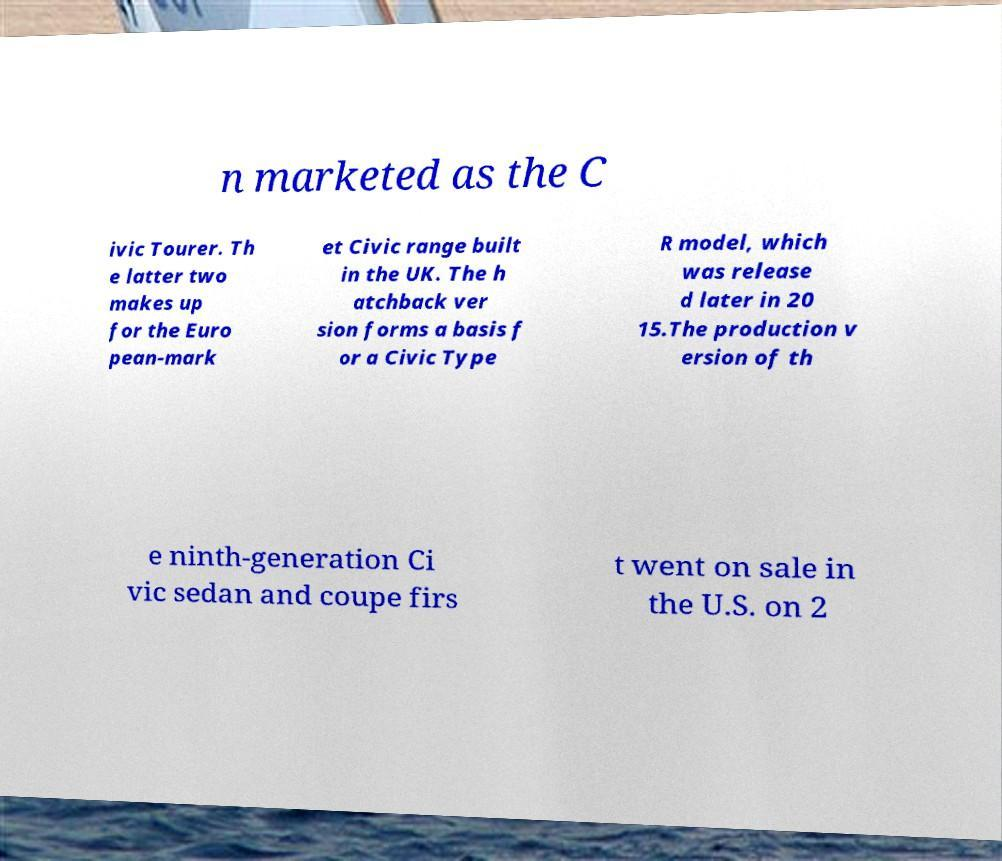Can you read and provide the text displayed in the image?This photo seems to have some interesting text. Can you extract and type it out for me? n marketed as the C ivic Tourer. Th e latter two makes up for the Euro pean-mark et Civic range built in the UK. The h atchback ver sion forms a basis f or a Civic Type R model, which was release d later in 20 15.The production v ersion of th e ninth-generation Ci vic sedan and coupe firs t went on sale in the U.S. on 2 